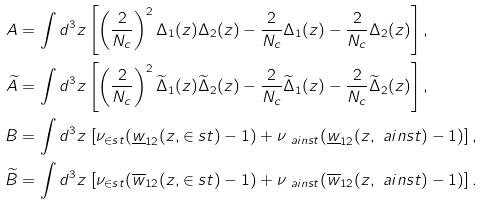Convert formula to latex. <formula><loc_0><loc_0><loc_500><loc_500>A & = \int d ^ { 3 } z \left [ \left ( \frac { 2 } { N _ { c } } \right ) ^ { 2 } \Delta _ { 1 } ( z ) \Delta _ { 2 } ( z ) - \frac { 2 } { N _ { c } } \Delta _ { 1 } ( z ) - \frac { 2 } { N _ { c } } \Delta _ { 2 } ( z ) \right ] , \\ \widetilde { A } & = \int d ^ { 3 } z \left [ \left ( \frac { 2 } { N _ { c } } \right ) ^ { 2 } \widetilde { \Delta } _ { 1 } ( z ) \widetilde { \Delta } _ { 2 } ( z ) - \frac { 2 } { N _ { c } } \widetilde { \Delta } _ { 1 } ( z ) - \frac { 2 } { N _ { c } } \widetilde { \Delta } _ { 2 } ( z ) \right ] , \\ B & = \int d ^ { 3 } z \, \left [ \nu _ { \in s t } ( \underline { w } _ { 1 2 } ( z , \in s t ) - 1 ) + \nu _ { \ a i n s t } ( \underline { w } _ { 1 2 } ( z , \ a i n s t ) - 1 ) \right ] , \\ \widetilde { B } & = \int d ^ { 3 } z \, \left [ \nu _ { \in s t } ( \overline { w } _ { 1 2 } ( z , \in s t ) - 1 ) + \nu _ { \ a i n s t } ( \overline { w } _ { 1 2 } ( z , \ a i n s t ) - 1 ) \right ] .</formula> 